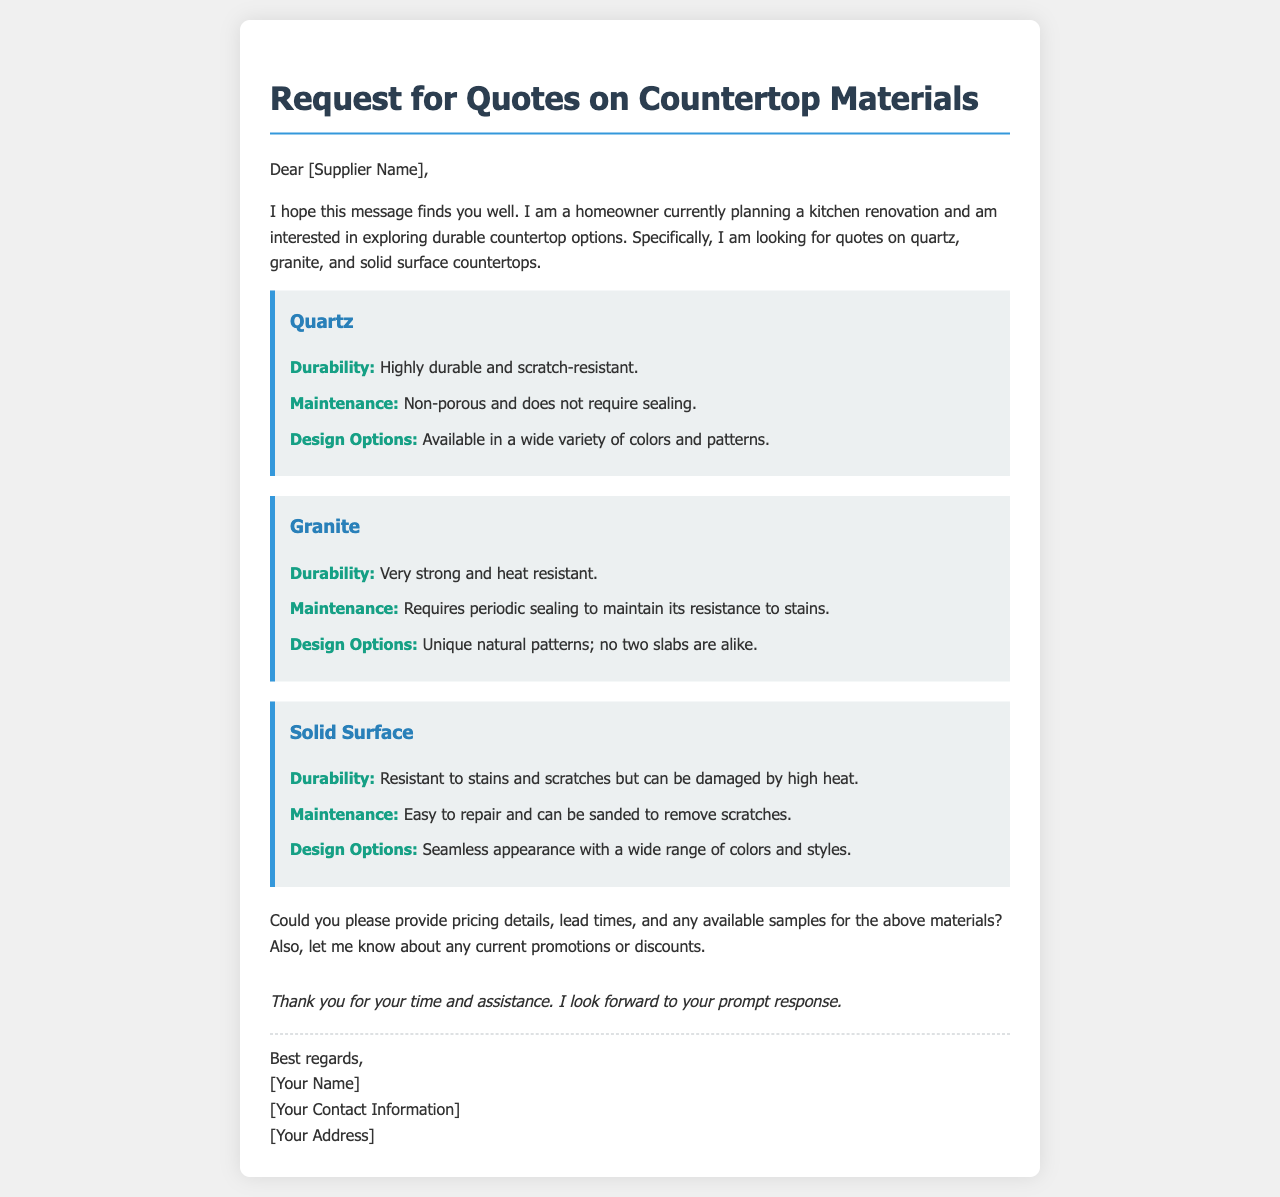what materials is the homeowner interested in? The homeowner is interested in quotes for quartz, granite, and solid surface countertops.
Answer: quartz, granite, solid surface what are the durability features of quartz? The document states that quartz is highly durable and scratch-resistant.
Answer: highly durable and scratch-resistant what type of maintenance does granite require? The maintenance section for granite indicates that it requires periodic sealing to maintain its resistance to stains.
Answer: periodic sealing how does the appearance of solid surface countertops differ from others? The document mentions that solid surface countertops have a seamless appearance with a wide range of colors and styles.
Answer: seamless appearance what information does the homeowner request from the suppliers? The homeowner requests pricing details, lead times, and any available samples for the materials.
Answer: pricing details, lead times, available samples which countertop material is noted for having unique natural patterns? The document specifies that granite has unique natural patterns, with no two slabs alike.
Answer: granite what is the closing remark in the email? The closing remark expresses the homeowner's gratitude and anticipation for a prompt response.
Answer: Thank you for your time and assistance. I look forward to your prompt response 